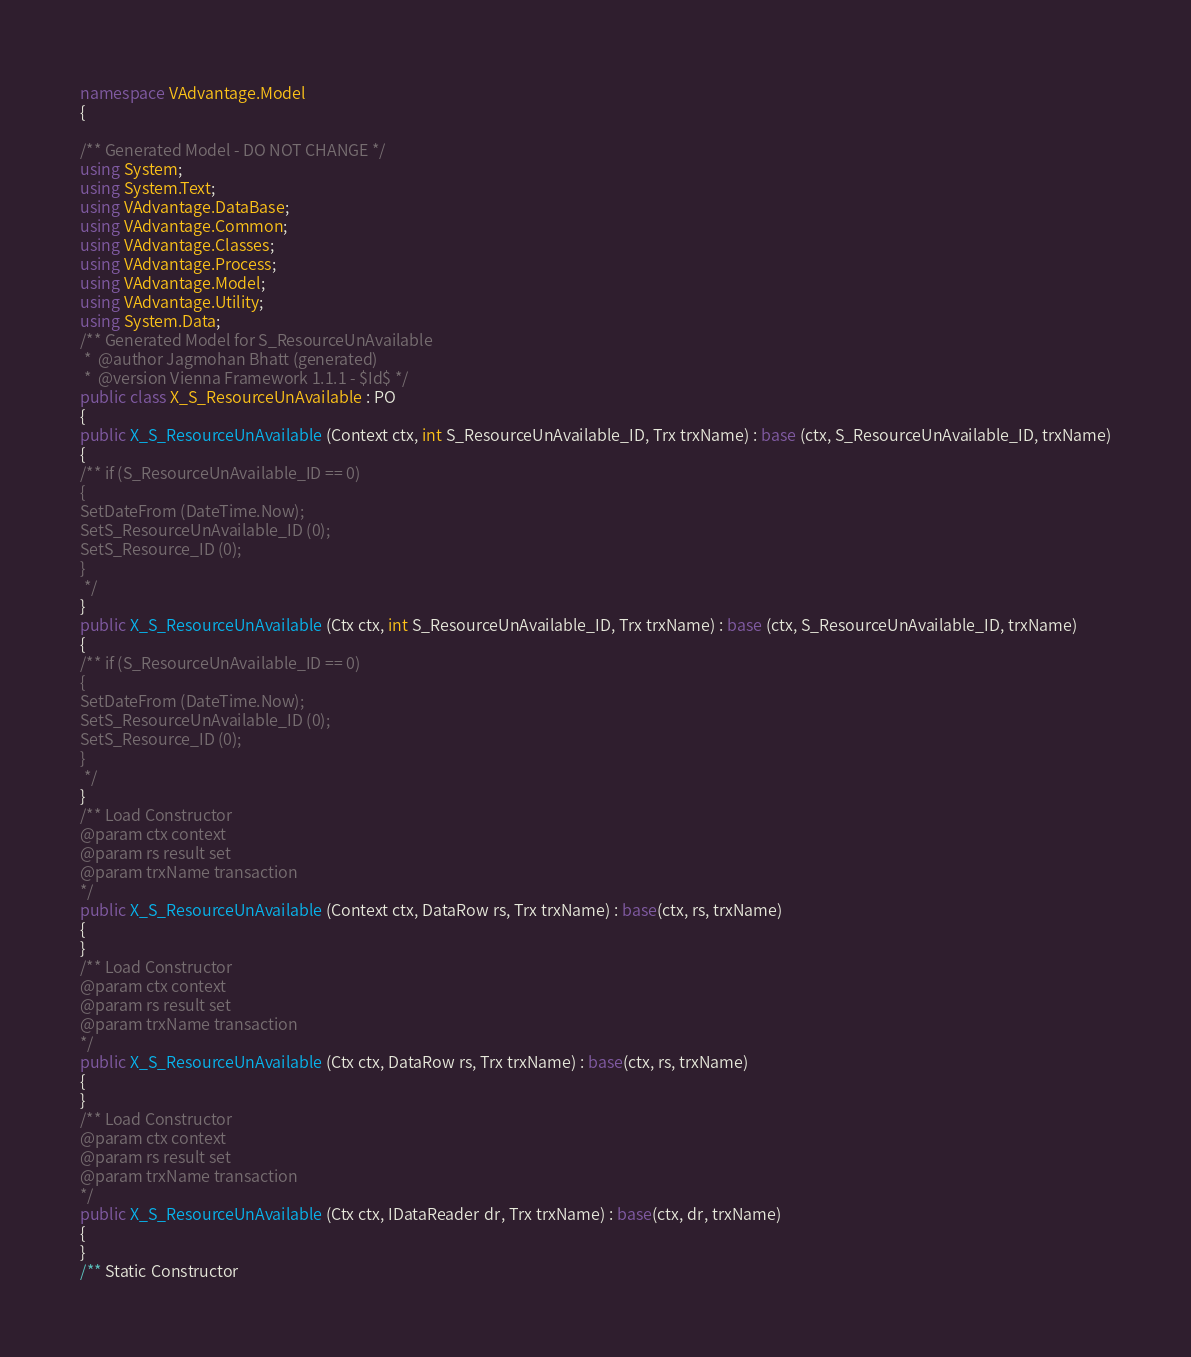<code> <loc_0><loc_0><loc_500><loc_500><_C#_>namespace VAdvantage.Model
{

/** Generated Model - DO NOT CHANGE */
using System;
using System.Text;
using VAdvantage.DataBase;
using VAdvantage.Common;
using VAdvantage.Classes;
using VAdvantage.Process;
using VAdvantage.Model;
using VAdvantage.Utility;
using System.Data;
/** Generated Model for S_ResourceUnAvailable
 *  @author Jagmohan Bhatt (generated) 
 *  @version Vienna Framework 1.1.1 - $Id$ */
public class X_S_ResourceUnAvailable : PO
{
public X_S_ResourceUnAvailable (Context ctx, int S_ResourceUnAvailable_ID, Trx trxName) : base (ctx, S_ResourceUnAvailable_ID, trxName)
{
/** if (S_ResourceUnAvailable_ID == 0)
{
SetDateFrom (DateTime.Now);
SetS_ResourceUnAvailable_ID (0);
SetS_Resource_ID (0);
}
 */
}
public X_S_ResourceUnAvailable (Ctx ctx, int S_ResourceUnAvailable_ID, Trx trxName) : base (ctx, S_ResourceUnAvailable_ID, trxName)
{
/** if (S_ResourceUnAvailable_ID == 0)
{
SetDateFrom (DateTime.Now);
SetS_ResourceUnAvailable_ID (0);
SetS_Resource_ID (0);
}
 */
}
/** Load Constructor 
@param ctx context
@param rs result set 
@param trxName transaction
*/
public X_S_ResourceUnAvailable (Context ctx, DataRow rs, Trx trxName) : base(ctx, rs, trxName)
{
}
/** Load Constructor 
@param ctx context
@param rs result set 
@param trxName transaction
*/
public X_S_ResourceUnAvailable (Ctx ctx, DataRow rs, Trx trxName) : base(ctx, rs, trxName)
{
}
/** Load Constructor 
@param ctx context
@param rs result set 
@param trxName transaction
*/
public X_S_ResourceUnAvailable (Ctx ctx, IDataReader dr, Trx trxName) : base(ctx, dr, trxName)
{
}
/** Static Constructor </code> 